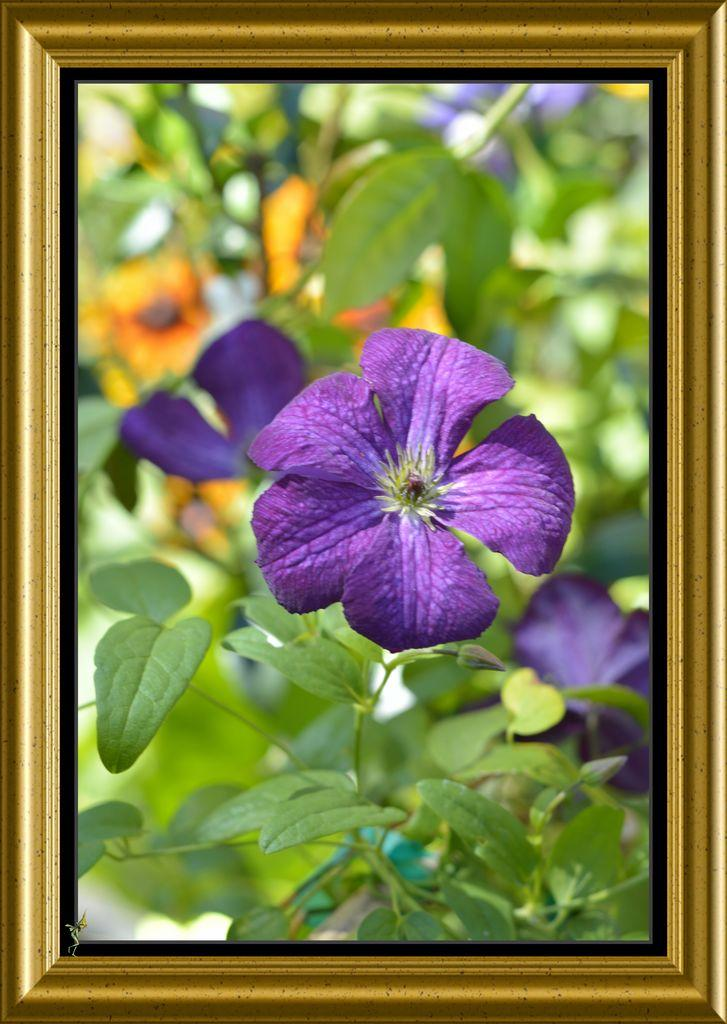What is the main subject of the image? The main subject of the image is a frame. What can be seen inside the frame? There are purple color flowers on a plant in the frame. What type of map can be seen in the image? There is no map present in the image. What arithmetic problem can be solved using the flowers in the image? The flowers in the image are not related to any arithmetic problem. 